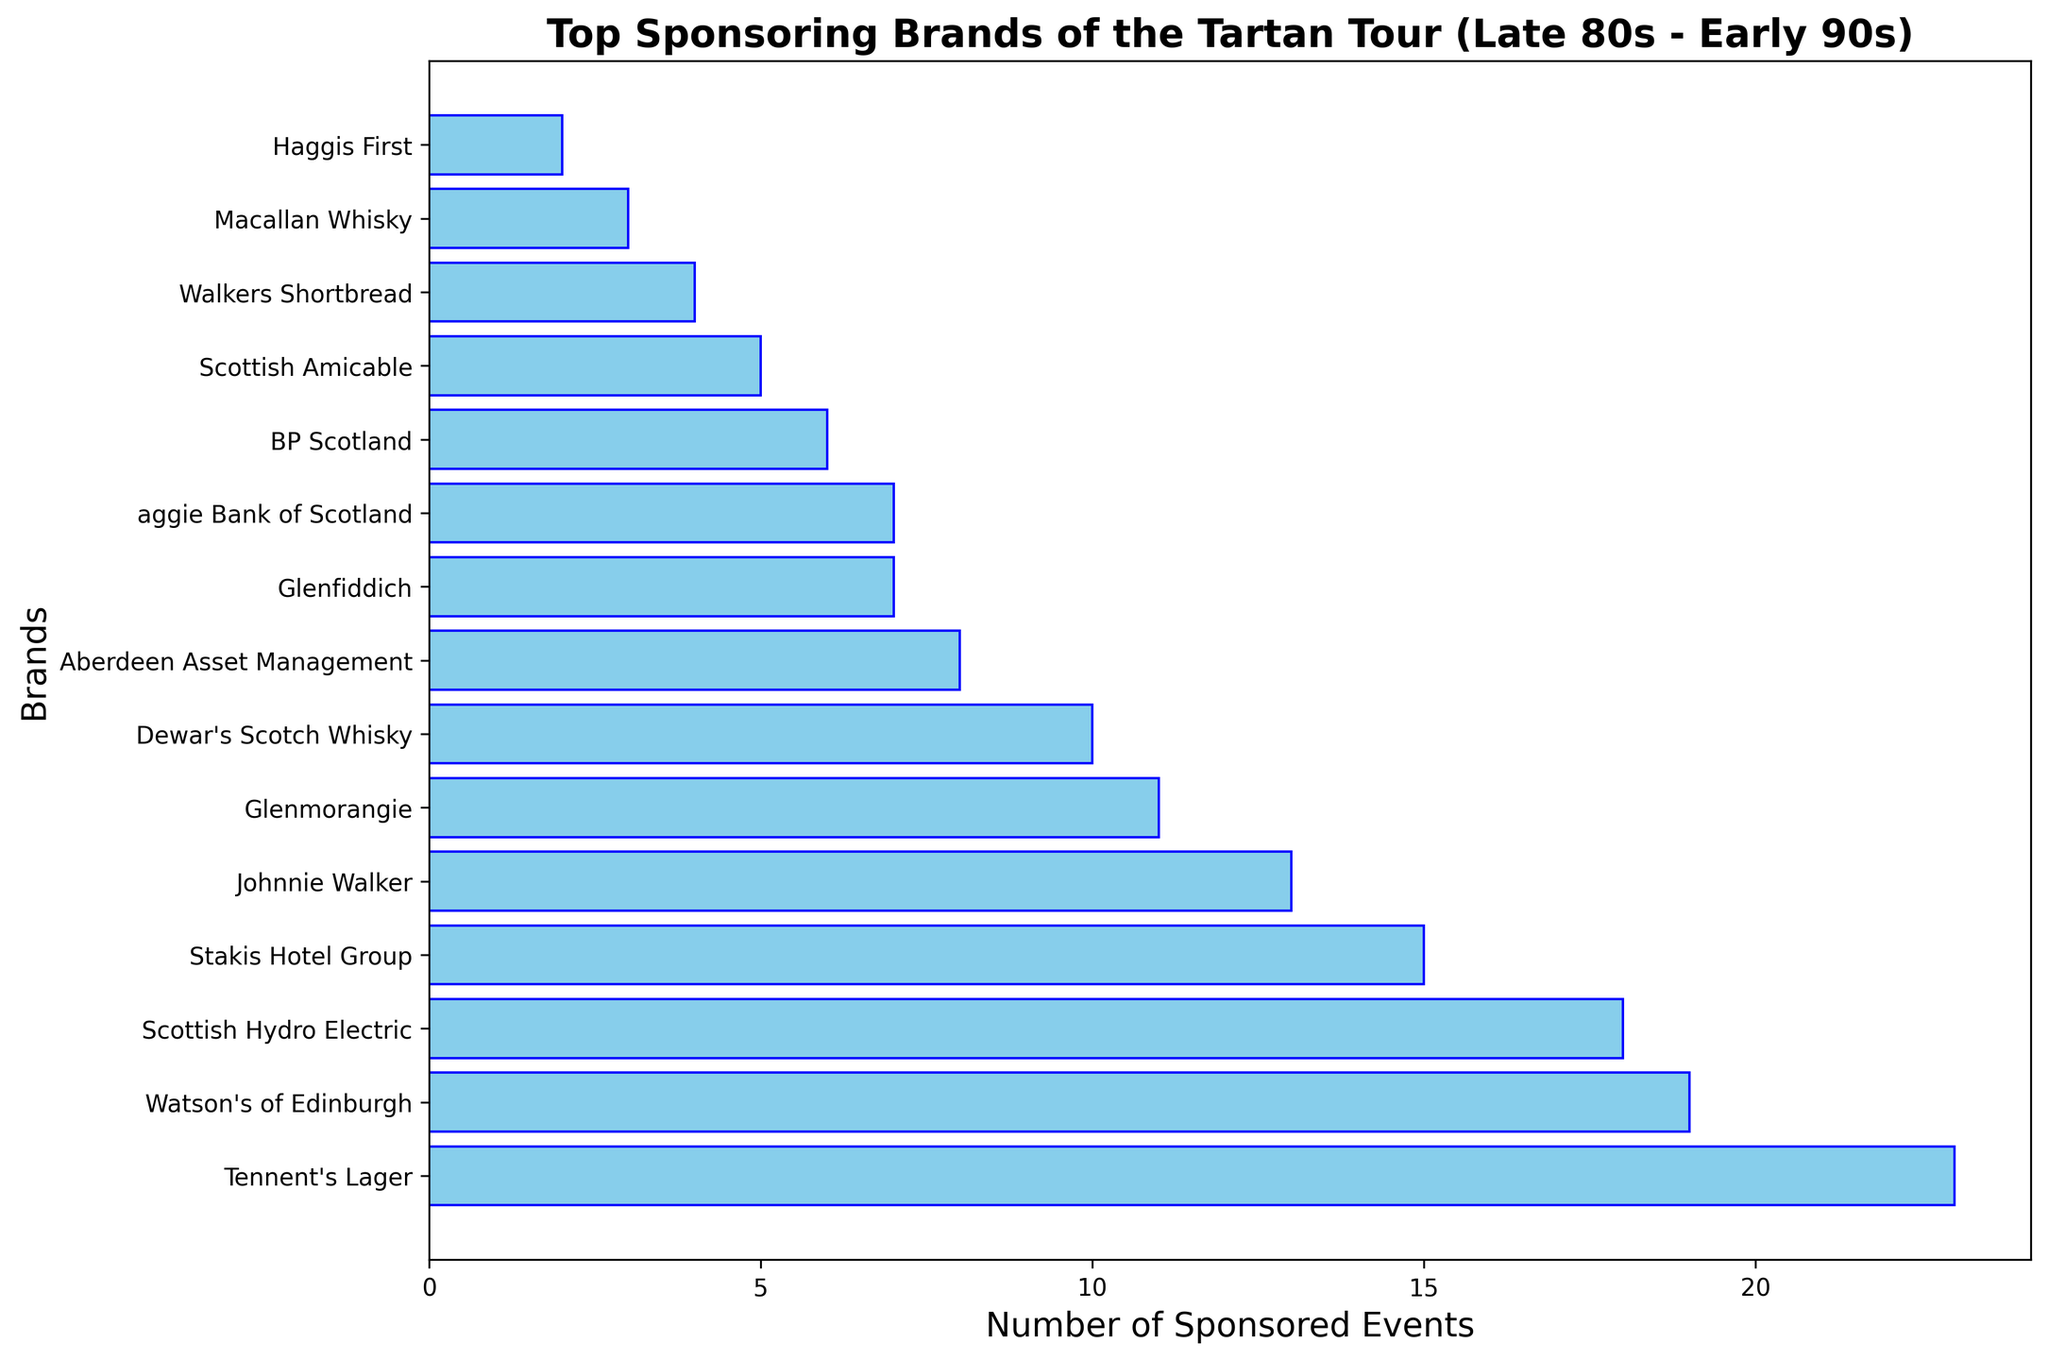What brand sponsored the most events? The tallest bar represents the brand that sponsored the most events, which is Tennent's Lager with 23 sponsored events.
Answer: Tennent's Lager What's the difference in the number of sponsored events between Tennent's Lager and Aberdeen Asset Management? Tennent's Lager sponsored 23 events, while Aberdeen Asset Management sponsored 8 events. The difference is 23 - 8.
Answer: 15 How many brands sponsored more than 10 events? Count the bars with heights indicating more than 10 sponsored events: Tennent's Lager, Watson's of Edinburgh, Scottish Hydro Electric, Stakis Hotel Group, Johnnie Walker, and Glenmorangie. That makes a total of 6 brands.
Answer: 6 What is the combined number of sponsored events by Dewar's Scotch Whisky, Glenfiddich, and Bank of Scotland? Sum the sponsored events: Dewar's Scotch Whisky (10) + Glenfiddich (7) + Bank of Scotland (7) = 24.
Answer: 24 Are there more brands that sponsored at least 10 events or those that sponsored fewer than 10 events? Brands with at least 10 events: Tennent's Lager, Watson's of Edinburgh, Scottish Hydro Electric, Stakis Hotel Group, Johnnie Walker, Glenmorangie, and Dewar's Scotch Whisky. That's 7 brands. Brands with fewer than 10 events: Aberdeen Asset Management, Glenfiddich, Bank of Scotland, BP Scotland, Scottish Amicable, Walkers Shortbread, Macallan Whisky, and Haggis First. That's 8 brands. 8 is more than 7.
Answer: Fewer than 10 events Which brand is more involved, Glenmorangie or Johnnie Walker? The bar representing Johnnie Walker is taller, showing 13 sponsored events, while Glenmorangie has 11.
Answer: Johnnie Walker What is the average number of sponsored events among the brands listed? Sum all the sponsored events (23 + 19 + 18 + 15 + 13 + 11 + 10 + 8 + 7 + 7 + 6 + 5 + 4 + 3 + 2 = 132) and divide by the number of brands (15). 132 / 15 = 8.8.
Answer: 8.8 By how many events does Watson's of Edinburgh exceed BP Scotland in sponsorships? Watson's of Edinburgh sponsored 19 events, while BP Scotland sponsored 6 events. The difference is 19 - 6.
Answer: 13 Which brand sponsored exactly 15 events? The bar with a length indicating 15 events represents the Stakis Hotel Group.
Answer: Stakis Hotel Group 